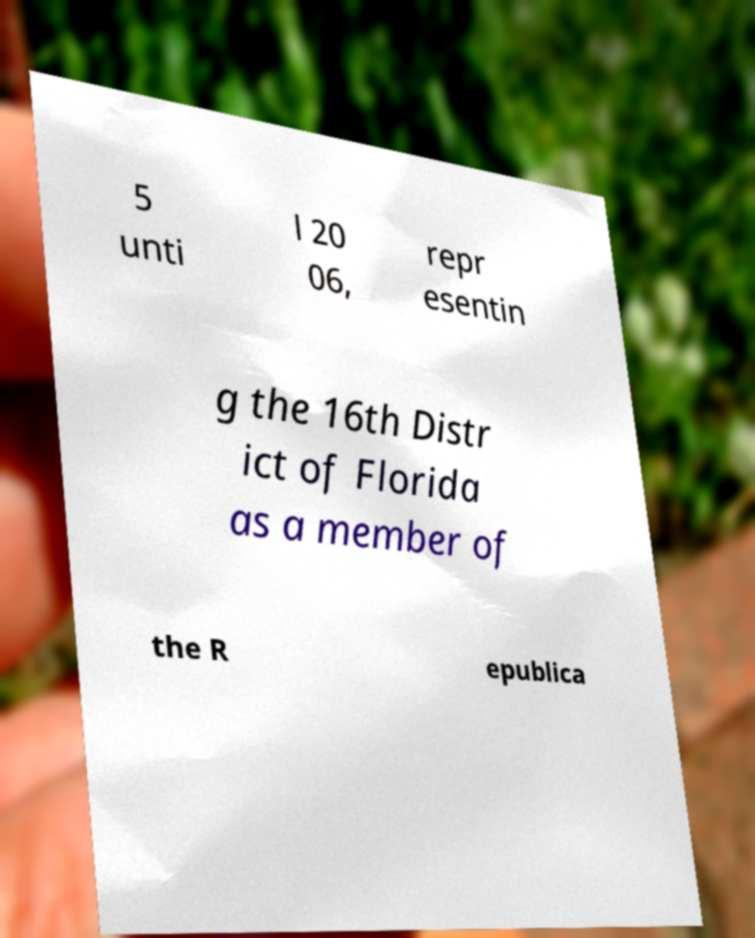There's text embedded in this image that I need extracted. Can you transcribe it verbatim? 5 unti l 20 06, repr esentin g the 16th Distr ict of Florida as a member of the R epublica 